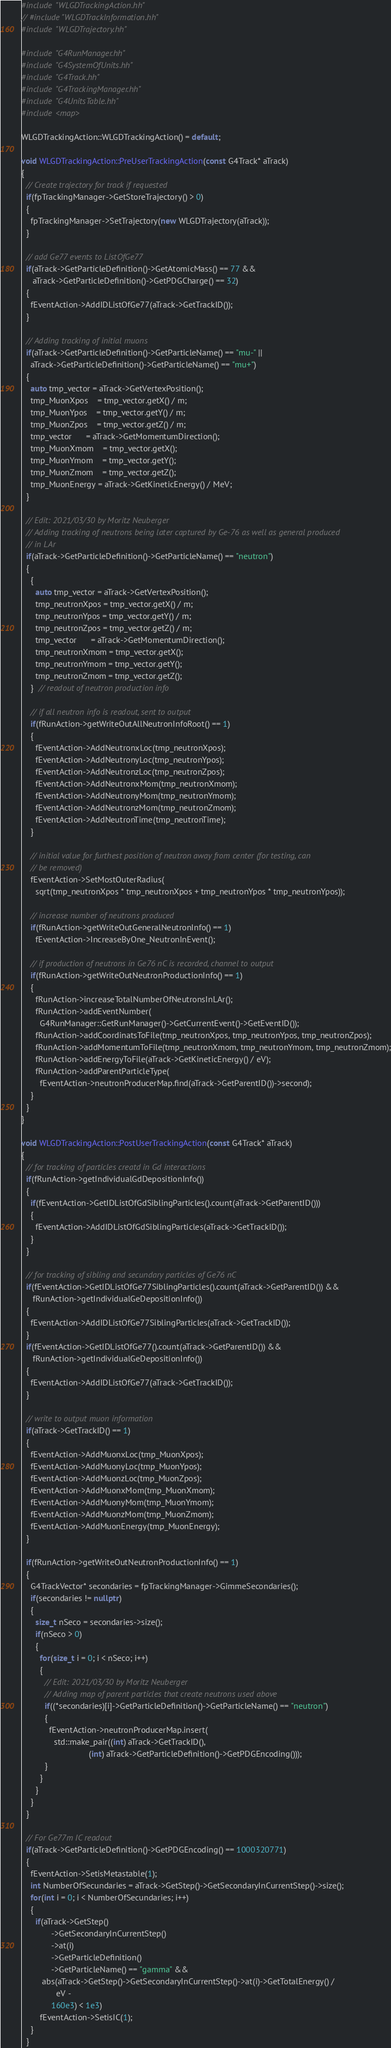Convert code to text. <code><loc_0><loc_0><loc_500><loc_500><_C++_>#include "WLGDTrackingAction.hh"
// #include "WLGDTrackInformation.hh"
#include "WLGDTrajectory.hh"

#include "G4RunManager.hh"
#include "G4SystemOfUnits.hh"
#include "G4Track.hh"
#include "G4TrackingManager.hh"
#include "G4UnitsTable.hh"
#include <map>

WLGDTrackingAction::WLGDTrackingAction() = default;

void WLGDTrackingAction::PreUserTrackingAction(const G4Track* aTrack)
{
  // Create trajectory for track if requested
  if(fpTrackingManager->GetStoreTrajectory() > 0)
  {
    fpTrackingManager->SetTrajectory(new WLGDTrajectory(aTrack));
  }

  // add Ge77 events to ListOfGe77
  if(aTrack->GetParticleDefinition()->GetAtomicMass() == 77 &&
     aTrack->GetParticleDefinition()->GetPDGCharge() == 32)
  {
    fEventAction->AddIDListOfGe77(aTrack->GetTrackID());
  }

  // Adding tracking of initial muons
  if(aTrack->GetParticleDefinition()->GetParticleName() == "mu-" ||
    aTrack->GetParticleDefinition()->GetParticleName() == "mu+")
  {
    auto tmp_vector = aTrack->GetVertexPosition();
    tmp_MuonXpos    = tmp_vector.getX() / m;
    tmp_MuonYpos    = tmp_vector.getY() / m;
    tmp_MuonZpos    = tmp_vector.getZ() / m;
    tmp_vector      = aTrack->GetMomentumDirection();
    tmp_MuonXmom    = tmp_vector.getX();
    tmp_MuonYmom    = tmp_vector.getY();
    tmp_MuonZmom    = tmp_vector.getZ();
    tmp_MuonEnergy = aTrack->GetKineticEnergy() / MeV;
  }

  // Edit: 2021/03/30 by Moritz Neuberger
  // Adding tracking of neutrons being later captured by Ge-76 as well as general produced
  // in LAr
  if(aTrack->GetParticleDefinition()->GetParticleName() == "neutron")
  {
    {
      auto tmp_vector = aTrack->GetVertexPosition();
      tmp_neutronXpos = tmp_vector.getX() / m;
      tmp_neutronYpos = tmp_vector.getY() / m;
      tmp_neutronZpos = tmp_vector.getZ() / m;
      tmp_vector      = aTrack->GetMomentumDirection();
      tmp_neutronXmom = tmp_vector.getX();
      tmp_neutronYmom = tmp_vector.getY();
      tmp_neutronZmom = tmp_vector.getZ();
    }  // readout of neutron production info

    // if all neutron info is readout, sent to output
    if(fRunAction->getWriteOutAllNeutronInfoRoot() == 1)
    {
      fEventAction->AddNeutronxLoc(tmp_neutronXpos);
      fEventAction->AddNeutronyLoc(tmp_neutronYpos);
      fEventAction->AddNeutronzLoc(tmp_neutronZpos);
      fEventAction->AddNeutronxMom(tmp_neutronXmom);
      fEventAction->AddNeutronyMom(tmp_neutronYmom);
      fEventAction->AddNeutronzMom(tmp_neutronZmom);
      fEventAction->AddNeutronTime(tmp_neutronTime);
    }

    // initial value for furthest position of neutron away from center (for testing, can
    // be removed)
    fEventAction->SetMostOuterRadius(
      sqrt(tmp_neutronXpos * tmp_neutronXpos + tmp_neutronYpos * tmp_neutronYpos));

    // increase number of neutrons produced
    if(fRunAction->getWriteOutGeneralNeutronInfo() == 1)
      fEventAction->IncreaseByOne_NeutronInEvent();

    // if production of neutrons in Ge76 nC is recorded, channel to output
    if(fRunAction->getWriteOutNeutronProductionInfo() == 1)
    {
      fRunAction->increaseTotalNumberOfNeutronsInLAr();
      fRunAction->addEventNumber(
        G4RunManager::GetRunManager()->GetCurrentEvent()->GetEventID());
      fRunAction->addCoordinatsToFile(tmp_neutronXpos, tmp_neutronYpos, tmp_neutronZpos);
      fRunAction->addMomentumToFile(tmp_neutronXmom, tmp_neutronYmom, tmp_neutronZmom);
      fRunAction->addEnergyToFile(aTrack->GetKineticEnergy() / eV);
      fRunAction->addParentParticleType(
        fEventAction->neutronProducerMap.find(aTrack->GetParentID())->second);
    }
  }
}

void WLGDTrackingAction::PostUserTrackingAction(const G4Track* aTrack)
{
  // for tracking of particles creatd in Gd interactions
  if(fRunAction->getIndividualGdDepositionInfo())
  {
    if(fEventAction->GetIDListOfGdSiblingParticles().count(aTrack->GetParentID()))
    {
      fEventAction->AddIDListOfGdSiblingParticles(aTrack->GetTrackID());
    }
  }

  // for tracking of sibling and secundary particles of Ge76 nC
  if(fEventAction->GetIDListOfGe77SiblingParticles().count(aTrack->GetParentID()) &&
     fRunAction->getIndividualGeDepositionInfo())
  {
    fEventAction->AddIDListOfGe77SiblingParticles(aTrack->GetTrackID());
  }
  if(fEventAction->GetIDListOfGe77().count(aTrack->GetParentID()) &&
     fRunAction->getIndividualGeDepositionInfo())
  {
    fEventAction->AddIDListOfGe77(aTrack->GetTrackID());
  }

  // write to output muon information
  if(aTrack->GetTrackID() == 1)
  {
    fEventAction->AddMuonxLoc(tmp_MuonXpos);
    fEventAction->AddMuonyLoc(tmp_MuonYpos);
    fEventAction->AddMuonzLoc(tmp_MuonZpos);
    fEventAction->AddMuonxMom(tmp_MuonXmom);
    fEventAction->AddMuonyMom(tmp_MuonYmom);
    fEventAction->AddMuonzMom(tmp_MuonZmom);
    fEventAction->AddMuonEnergy(tmp_MuonEnergy);
  }

  if(fRunAction->getWriteOutNeutronProductionInfo() == 1)
  {
    G4TrackVector* secondaries = fpTrackingManager->GimmeSecondaries();
    if(secondaries != nullptr)
    {
      size_t nSeco = secondaries->size();
      if(nSeco > 0)
      {
        for(size_t i = 0; i < nSeco; i++)
        {
          // Edit: 2021/03/30 by Moritz Neuberger
          // Adding map of parent particles that create neutrons used above
          if((*secondaries)[i]->GetParticleDefinition()->GetParticleName() == "neutron")
          {
            fEventAction->neutronProducerMap.insert(
              std::make_pair((int) aTrack->GetTrackID(),
                             (int) aTrack->GetParticleDefinition()->GetPDGEncoding()));
          }
        }
      }
    }
  }

  // For Ge77m IC readout
  if(aTrack->GetParticleDefinition()->GetPDGEncoding() == 1000320771)
  {
    fEventAction->SetisMetastable(1);
    int NumberOfSecundaries = aTrack->GetStep()->GetSecondaryInCurrentStep()->size();
    for(int i = 0; i < NumberOfSecundaries; i++)
    {
      if(aTrack->GetStep()
             ->GetSecondaryInCurrentStep()
             ->at(i)
             ->GetParticleDefinition()
             ->GetParticleName() == "gamma" &&
         abs(aTrack->GetStep()->GetSecondaryInCurrentStep()->at(i)->GetTotalEnergy() /
               eV -
             160e3) < 1e3)
        fEventAction->SetisIC(1);
    }
  }
</code> 